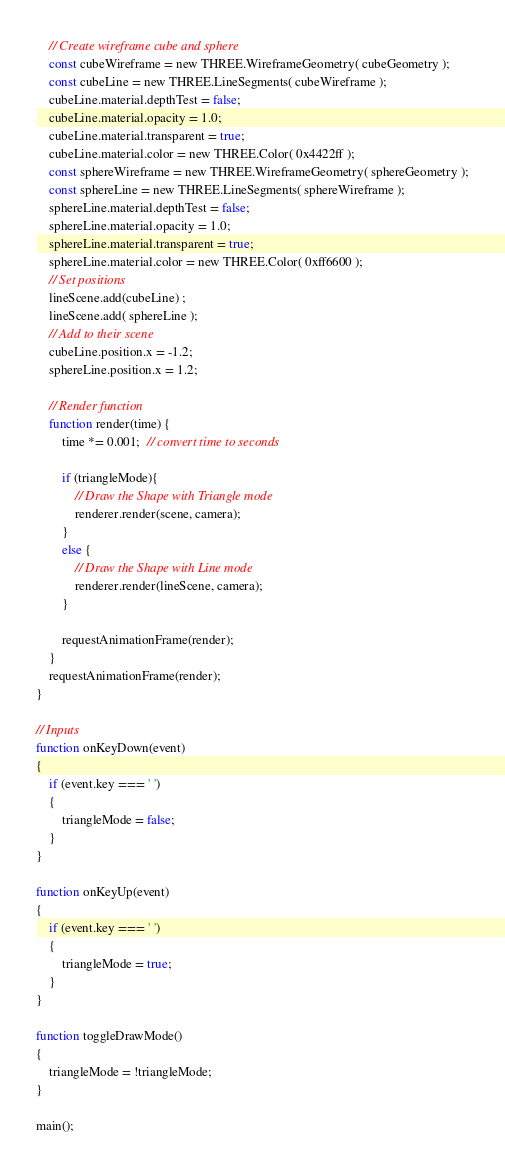<code> <loc_0><loc_0><loc_500><loc_500><_JavaScript_>    // Create wireframe cube and sphere
    const cubeWireframe = new THREE.WireframeGeometry( cubeGeometry );
    const cubeLine = new THREE.LineSegments( cubeWireframe );
    cubeLine.material.depthTest = false;
    cubeLine.material.opacity = 1.0;
    cubeLine.material.transparent = true;
    cubeLine.material.color = new THREE.Color( 0x4422ff );
    const sphereWireframe = new THREE.WireframeGeometry( sphereGeometry );
    const sphereLine = new THREE.LineSegments( sphereWireframe );
    sphereLine.material.depthTest = false;
    sphereLine.material.opacity = 1.0;
    sphereLine.material.transparent = true;
    sphereLine.material.color = new THREE.Color( 0xff6600 );
    // Set positions
    lineScene.add(cubeLine) ;
    lineScene.add( sphereLine );
    // Add to their scene
    cubeLine.position.x = -1.2;
    sphereLine.position.x = 1.2;

    // Render function
    function render(time) {
        time *= 0.001;  // convert time to seconds

        if (triangleMode){
            // Draw the Shape with Triangle mode
            renderer.render(scene, camera);
        }
        else {
            // Draw the Shape with Line mode
            renderer.render(lineScene, camera);
        }

        requestAnimationFrame(render);
    }
    requestAnimationFrame(render);
}

// Inputs
function onKeyDown(event)
{
    if (event.key === ' ')
    {
        triangleMode = false;
    }
}

function onKeyUp(event)
{
    if (event.key === ' ')
    {
        triangleMode = true;
    }
}

function toggleDrawMode()
{
    triangleMode = !triangleMode;
}

main();
</code> 